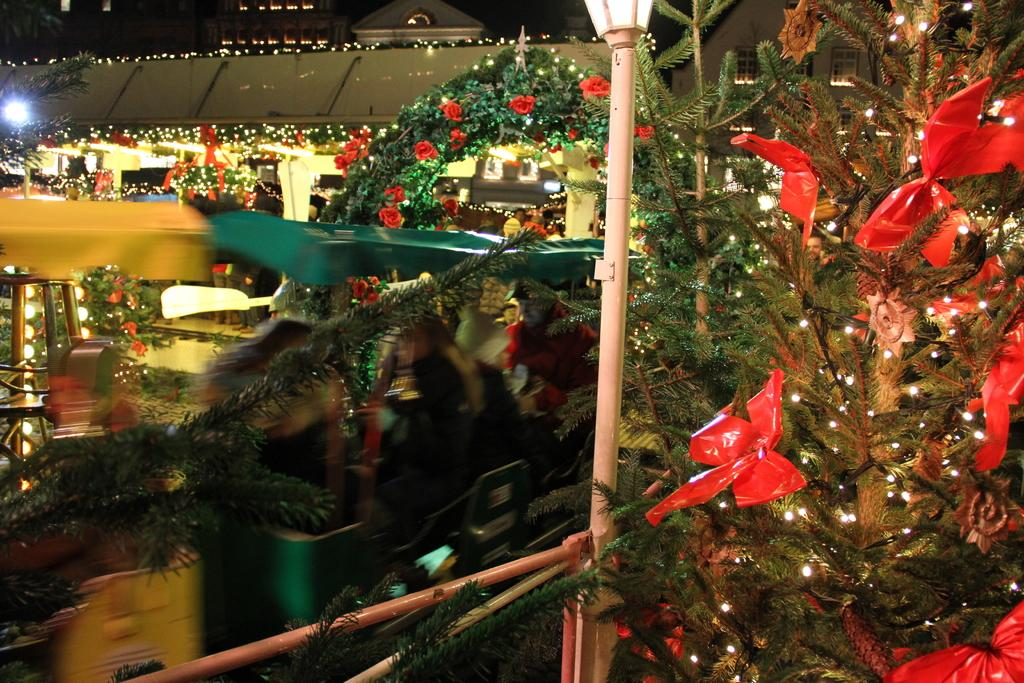What type of vegetation can be seen in the image? There are trees in the image. What is added to the trees to make them stand out? There are lights on the trees. What structures can be seen at the top of the image? There are two buildings visible at the top of the image. What suggestion does the self-driving car make in the image? There is no self-driving car present in the image, so it cannot make any suggestions. 